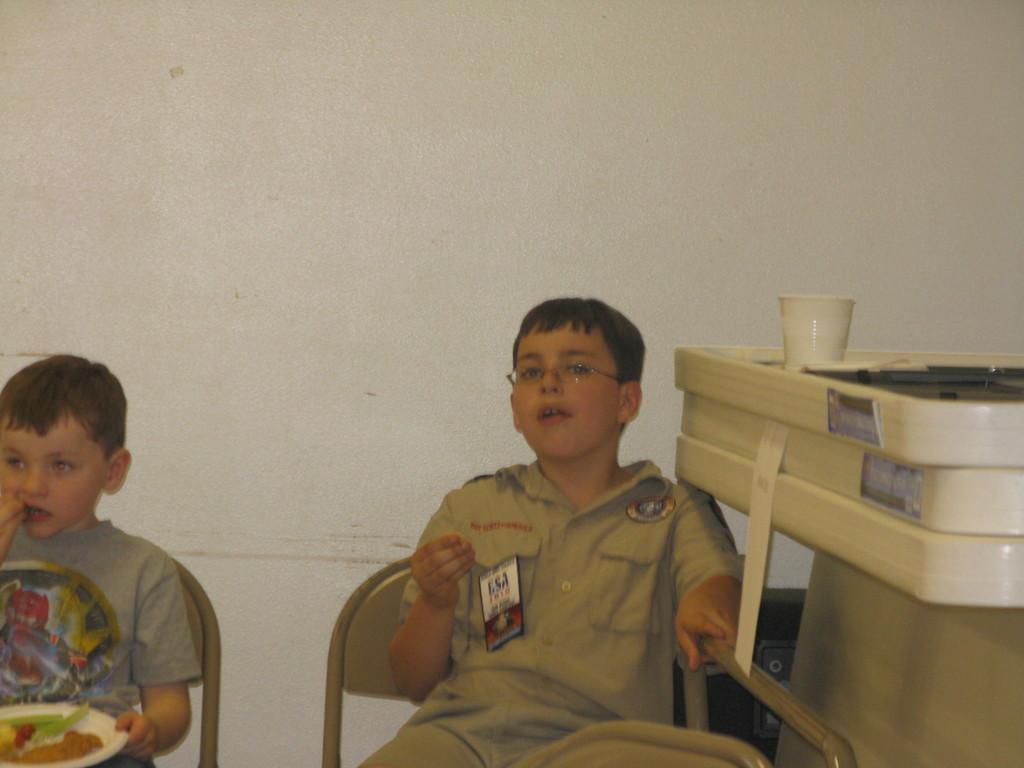Please provide a concise description of this image. In the image there are two kids sitting on the chairs in front of the wall and on the right side there is a cup kept on some object. 